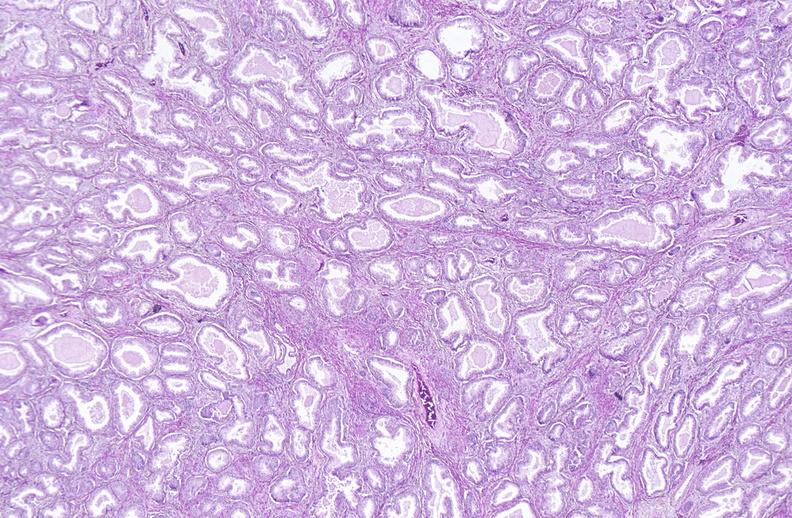what does this image show?
Answer the question using a single word or phrase. Prostate 